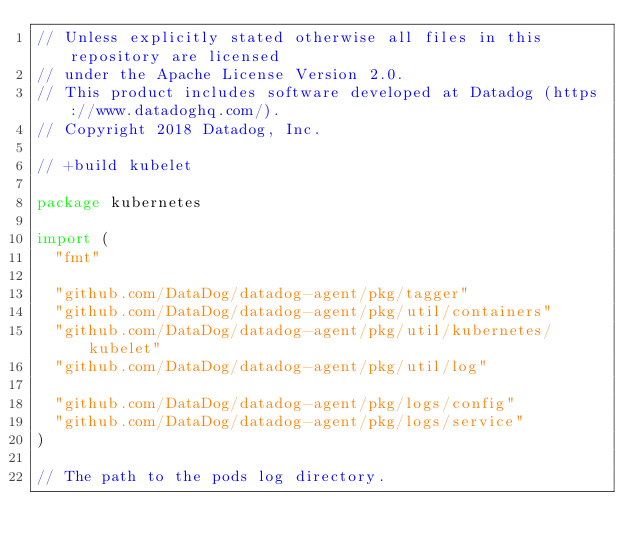Convert code to text. <code><loc_0><loc_0><loc_500><loc_500><_Go_>// Unless explicitly stated otherwise all files in this repository are licensed
// under the Apache License Version 2.0.
// This product includes software developed at Datadog (https://www.datadoghq.com/).
// Copyright 2018 Datadog, Inc.

// +build kubelet

package kubernetes

import (
	"fmt"

	"github.com/DataDog/datadog-agent/pkg/tagger"
	"github.com/DataDog/datadog-agent/pkg/util/containers"
	"github.com/DataDog/datadog-agent/pkg/util/kubernetes/kubelet"
	"github.com/DataDog/datadog-agent/pkg/util/log"

	"github.com/DataDog/datadog-agent/pkg/logs/config"
	"github.com/DataDog/datadog-agent/pkg/logs/service"
)

// The path to the pods log directory.</code> 